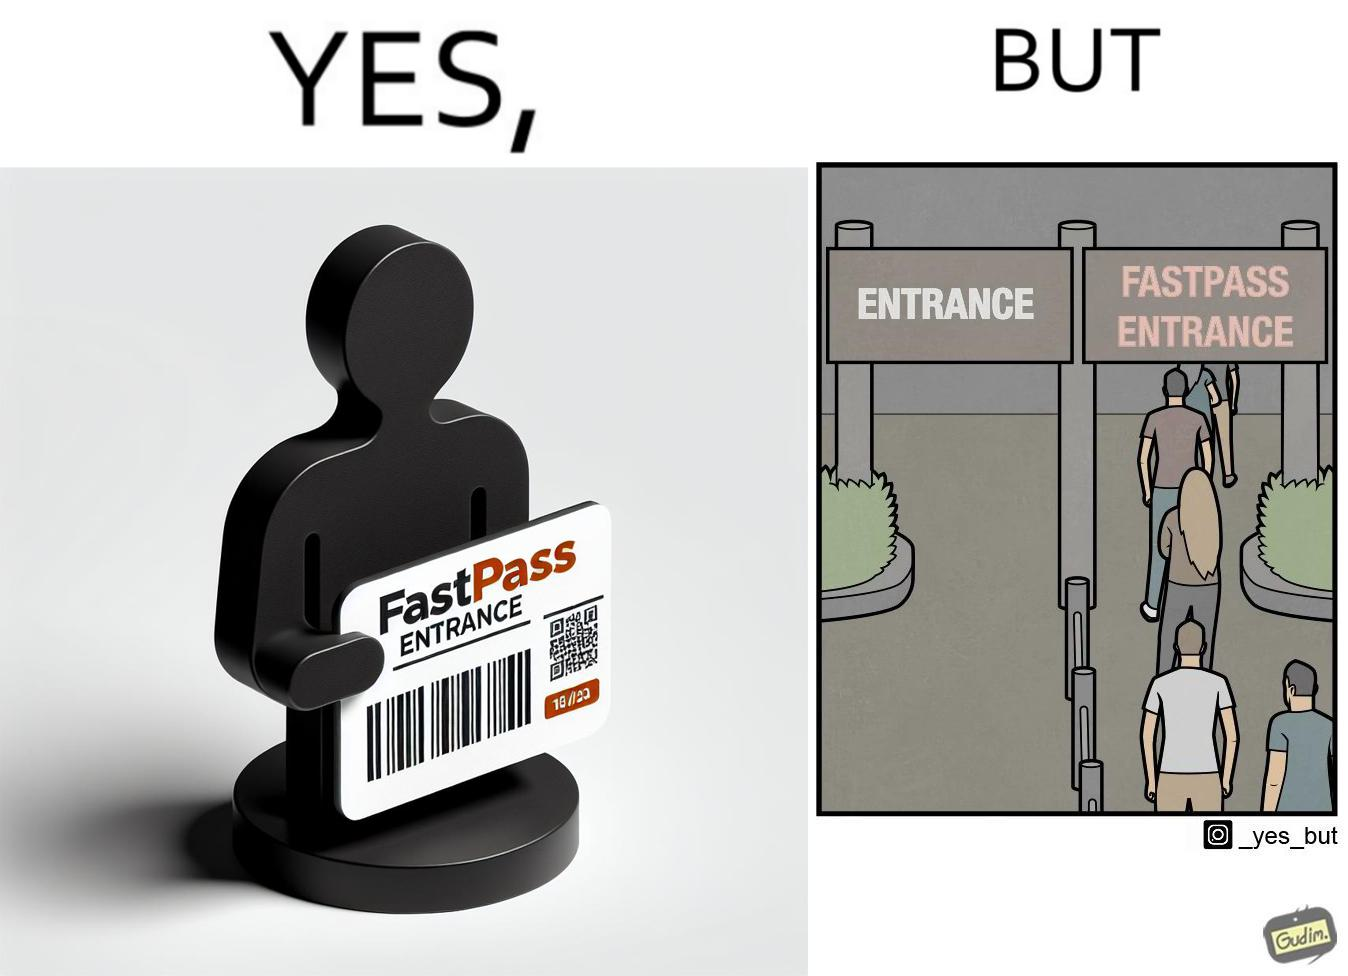Describe what you see in the left and right parts of this image. In the left part of the image: a person holding a "FASTPASS ENTRANCE" ticket or token of date "15/05/23" with some barcode In the right part of the image: people in a long queue in front of "FASTPASS ENTRANCE"  gate and "ENTRANCE" gate is vacant without any queue 